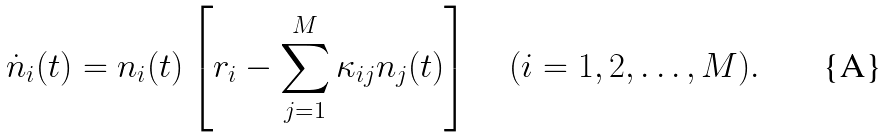Convert formula to latex. <formula><loc_0><loc_0><loc_500><loc_500>\dot { n } _ { i } ( t ) = n _ { i } ( t ) \left [ r _ { i } - \sum _ { j = 1 } ^ { M } \kappa _ { i j } n _ { j } ( t ) \right ] \quad ( i = 1 , 2 , \dots , M ) .</formula> 